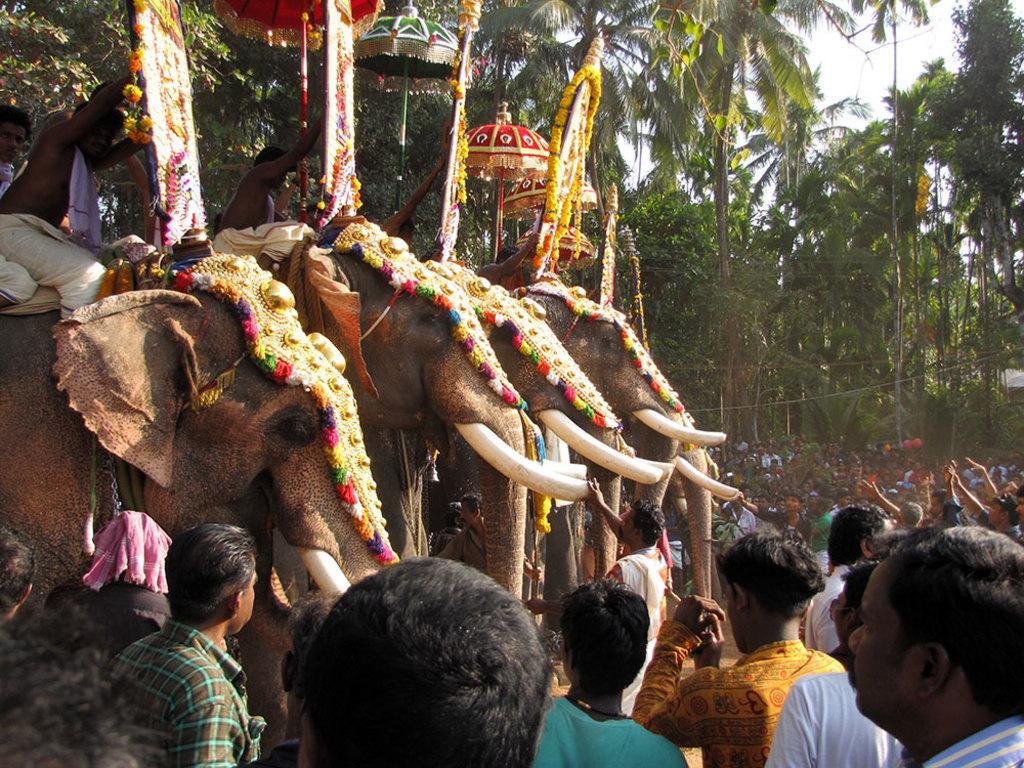Could you give a brief overview of what you see in this image? This image is clicked outside. In this there are elephants and many people. To the left, there is a elephant on which two persons are sitting. In the background, there are many trees and sky. 